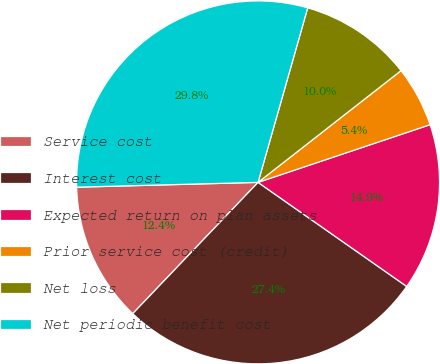Convert chart to OTSL. <chart><loc_0><loc_0><loc_500><loc_500><pie_chart><fcel>Service cost<fcel>Interest cost<fcel>Expected return on plan assets<fcel>Prior service cost (credit)<fcel>Net loss<fcel>Net periodic benefit cost<nl><fcel>12.45%<fcel>27.41%<fcel>14.87%<fcel>5.41%<fcel>10.03%<fcel>29.83%<nl></chart> 